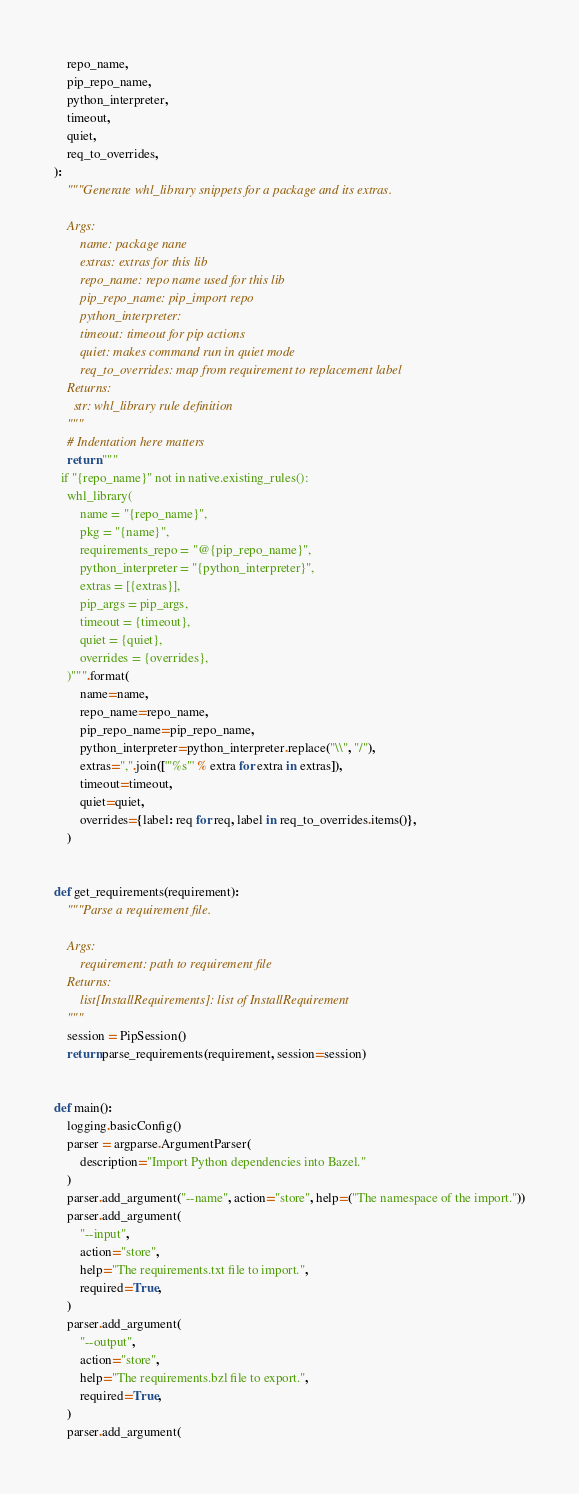Convert code to text. <code><loc_0><loc_0><loc_500><loc_500><_Python_>    repo_name,
    pip_repo_name,
    python_interpreter,
    timeout,
    quiet,
    req_to_overrides,
):
    """Generate whl_library snippets for a package and its extras.

    Args:
        name: package nane
        extras: extras for this lib
        repo_name: repo name used for this lib
        pip_repo_name: pip_import repo
        python_interpreter:
        timeout: timeout for pip actions
        quiet: makes command run in quiet mode
        req_to_overrides: map from requirement to replacement label
    Returns:
      str: whl_library rule definition
    """
    # Indentation here matters
    return """
  if "{repo_name}" not in native.existing_rules():
    whl_library(
        name = "{repo_name}",
        pkg = "{name}",
        requirements_repo = "@{pip_repo_name}",
        python_interpreter = "{python_interpreter}",
        extras = [{extras}],
        pip_args = pip_args,
        timeout = {timeout},
        quiet = {quiet},
        overrides = {overrides},
    )""".format(
        name=name,
        repo_name=repo_name,
        pip_repo_name=pip_repo_name,
        python_interpreter=python_interpreter.replace("\\", "/"),
        extras=",".join(['"%s"' % extra for extra in extras]),
        timeout=timeout,
        quiet=quiet,
        overrides={label: req for req, label in req_to_overrides.items()},
    )


def get_requirements(requirement):
    """Parse a requirement file.

    Args:
        requirement: path to requirement file
    Returns:
        list[InstallRequirements]: list of InstallRequirement
    """
    session = PipSession()
    return parse_requirements(requirement, session=session)


def main():
    logging.basicConfig()
    parser = argparse.ArgumentParser(
        description="Import Python dependencies into Bazel."
    )
    parser.add_argument("--name", action="store", help=("The namespace of the import."))
    parser.add_argument(
        "--input",
        action="store",
        help="The requirements.txt file to import.",
        required=True,
    )
    parser.add_argument(
        "--output",
        action="store",
        help="The requirements.bzl file to export.",
        required=True,
    )
    parser.add_argument(</code> 